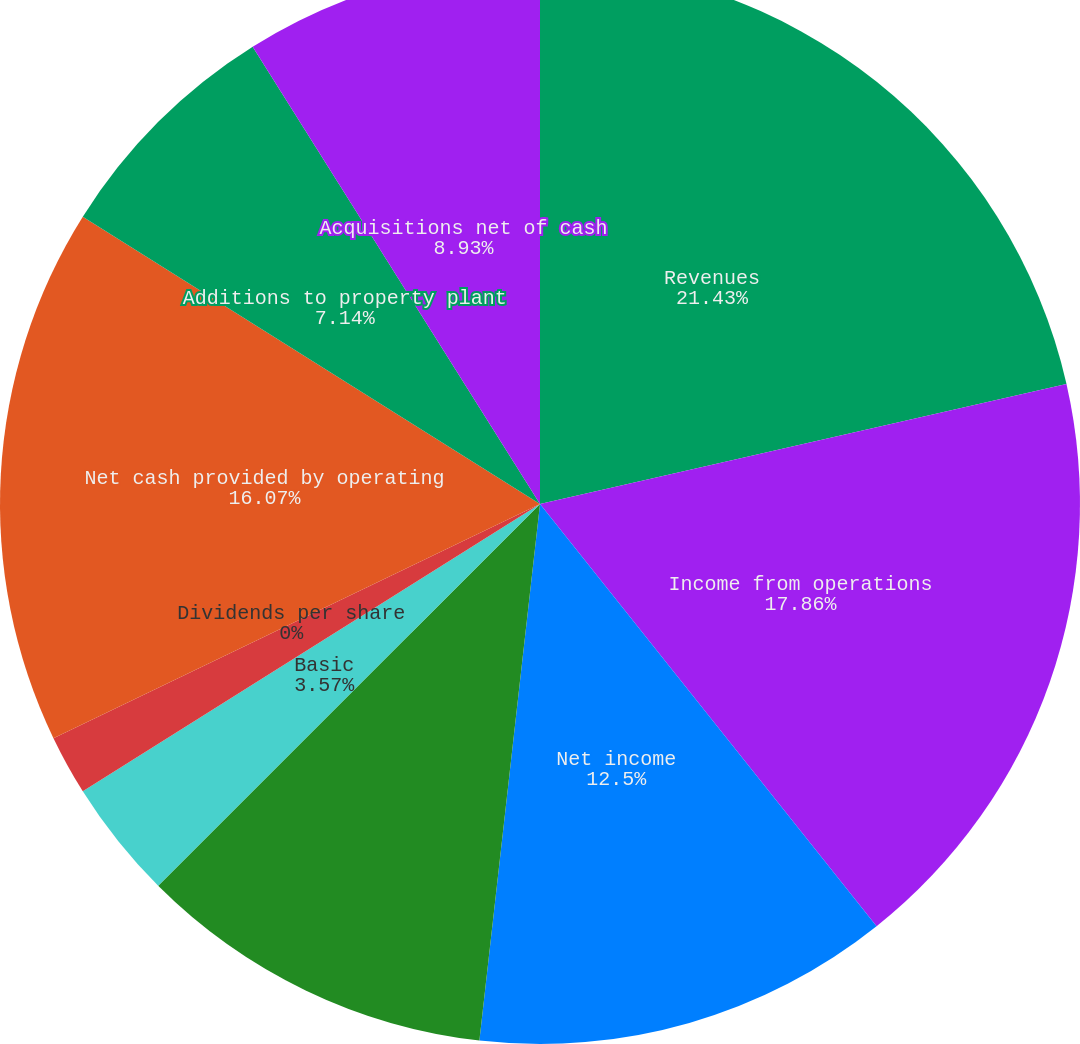Convert chart to OTSL. <chart><loc_0><loc_0><loc_500><loc_500><pie_chart><fcel>Revenues<fcel>Income from operations<fcel>Net income<fcel>Net income attributable to MPC<fcel>Basic<fcel>Diluted<fcel>Dividends per share<fcel>Net cash provided by operating<fcel>Additions to property plant<fcel>Acquisitions net of cash<nl><fcel>21.43%<fcel>17.86%<fcel>12.5%<fcel>10.71%<fcel>3.57%<fcel>1.79%<fcel>0.0%<fcel>16.07%<fcel>7.14%<fcel>8.93%<nl></chart> 